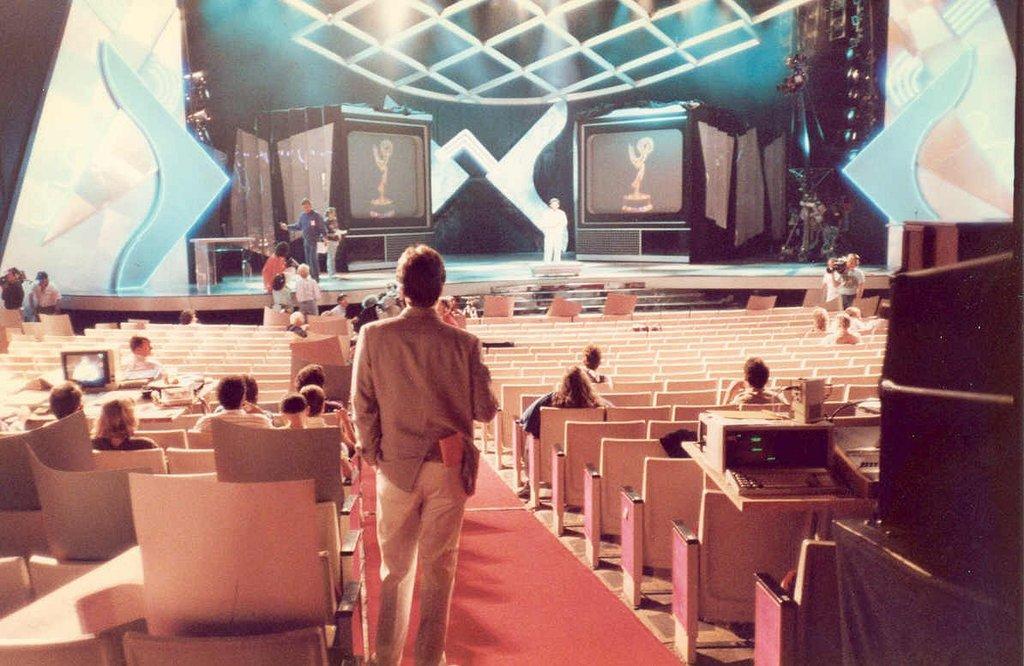Describe this image in one or two sentences. In this picture we can see some people are sitting on chairs and some people are standing on the floor and some people are on stage, carpets, devices, lights and some objects. 